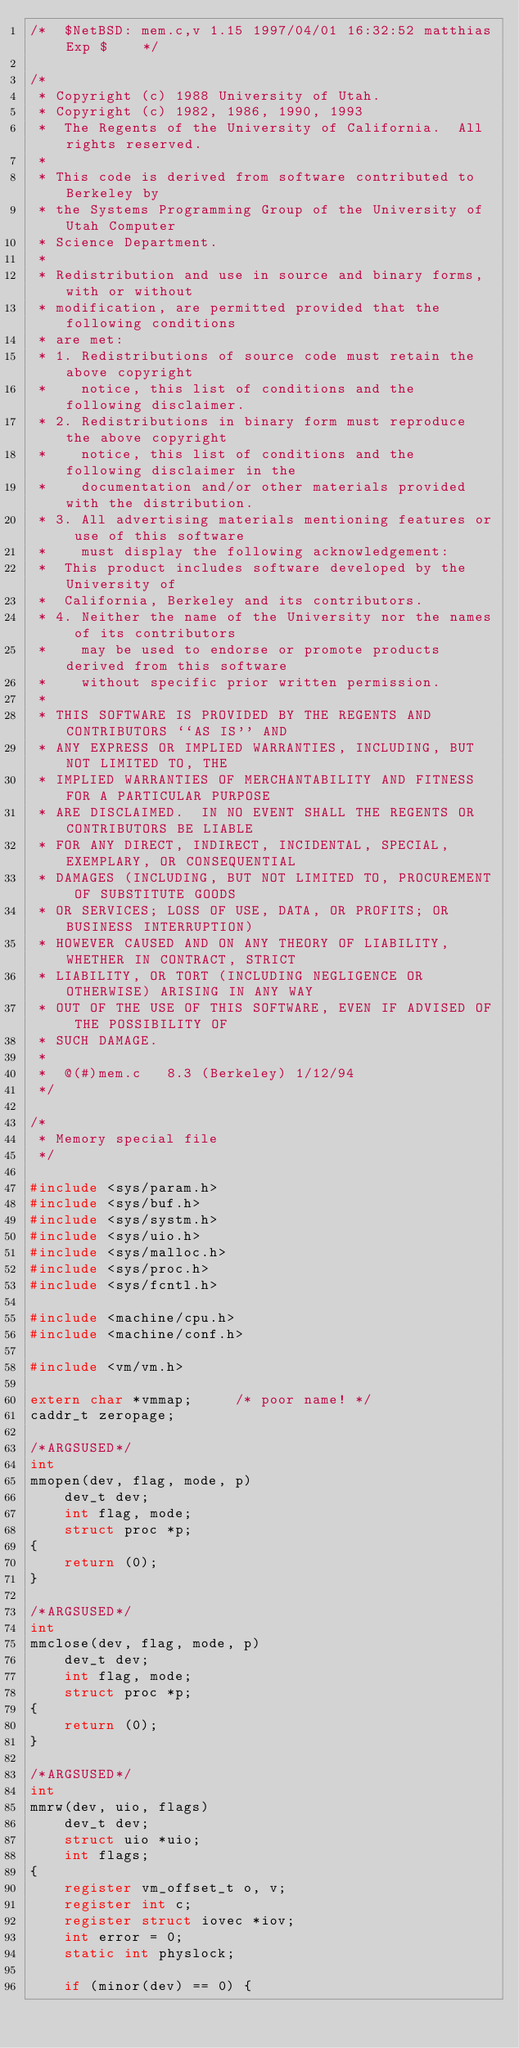Convert code to text. <code><loc_0><loc_0><loc_500><loc_500><_C_>/*	$NetBSD: mem.c,v 1.15 1997/04/01 16:32:52 matthias Exp $	*/

/*
 * Copyright (c) 1988 University of Utah.
 * Copyright (c) 1982, 1986, 1990, 1993
 *	The Regents of the University of California.  All rights reserved.
 *
 * This code is derived from software contributed to Berkeley by
 * the Systems Programming Group of the University of Utah Computer
 * Science Department.
 *
 * Redistribution and use in source and binary forms, with or without
 * modification, are permitted provided that the following conditions
 * are met:
 * 1. Redistributions of source code must retain the above copyright
 *    notice, this list of conditions and the following disclaimer.
 * 2. Redistributions in binary form must reproduce the above copyright
 *    notice, this list of conditions and the following disclaimer in the
 *    documentation and/or other materials provided with the distribution.
 * 3. All advertising materials mentioning features or use of this software
 *    must display the following acknowledgement:
 *	This product includes software developed by the University of
 *	California, Berkeley and its contributors.
 * 4. Neither the name of the University nor the names of its contributors
 *    may be used to endorse or promote products derived from this software
 *    without specific prior written permission.
 *
 * THIS SOFTWARE IS PROVIDED BY THE REGENTS AND CONTRIBUTORS ``AS IS'' AND
 * ANY EXPRESS OR IMPLIED WARRANTIES, INCLUDING, BUT NOT LIMITED TO, THE
 * IMPLIED WARRANTIES OF MERCHANTABILITY AND FITNESS FOR A PARTICULAR PURPOSE
 * ARE DISCLAIMED.  IN NO EVENT SHALL THE REGENTS OR CONTRIBUTORS BE LIABLE
 * FOR ANY DIRECT, INDIRECT, INCIDENTAL, SPECIAL, EXEMPLARY, OR CONSEQUENTIAL
 * DAMAGES (INCLUDING, BUT NOT LIMITED TO, PROCUREMENT OF SUBSTITUTE GOODS
 * OR SERVICES; LOSS OF USE, DATA, OR PROFITS; OR BUSINESS INTERRUPTION)
 * HOWEVER CAUSED AND ON ANY THEORY OF LIABILITY, WHETHER IN CONTRACT, STRICT
 * LIABILITY, OR TORT (INCLUDING NEGLIGENCE OR OTHERWISE) ARISING IN ANY WAY
 * OUT OF THE USE OF THIS SOFTWARE, EVEN IF ADVISED OF THE POSSIBILITY OF
 * SUCH DAMAGE.
 *
 *	@(#)mem.c	8.3 (Berkeley) 1/12/94
 */

/*
 * Memory special file
 */

#include <sys/param.h>
#include <sys/buf.h>
#include <sys/systm.h>
#include <sys/uio.h>
#include <sys/malloc.h>
#include <sys/proc.h>
#include <sys/fcntl.h>

#include <machine/cpu.h>
#include <machine/conf.h>

#include <vm/vm.h>

extern char *vmmap;		/* poor name! */
caddr_t zeropage;

/*ARGSUSED*/
int
mmopen(dev, flag, mode, p)
	dev_t dev;
	int flag, mode;
	struct proc *p;
{
	return (0);
}

/*ARGSUSED*/
int
mmclose(dev, flag, mode, p)
	dev_t dev;
	int flag, mode;
	struct proc *p;
{
	return (0);
}

/*ARGSUSED*/
int
mmrw(dev, uio, flags)
	dev_t dev;
	struct uio *uio;
	int flags;
{
	register vm_offset_t o, v;
	register int c;
	register struct iovec *iov;
	int error = 0;
	static int physlock;

	if (minor(dev) == 0) {</code> 